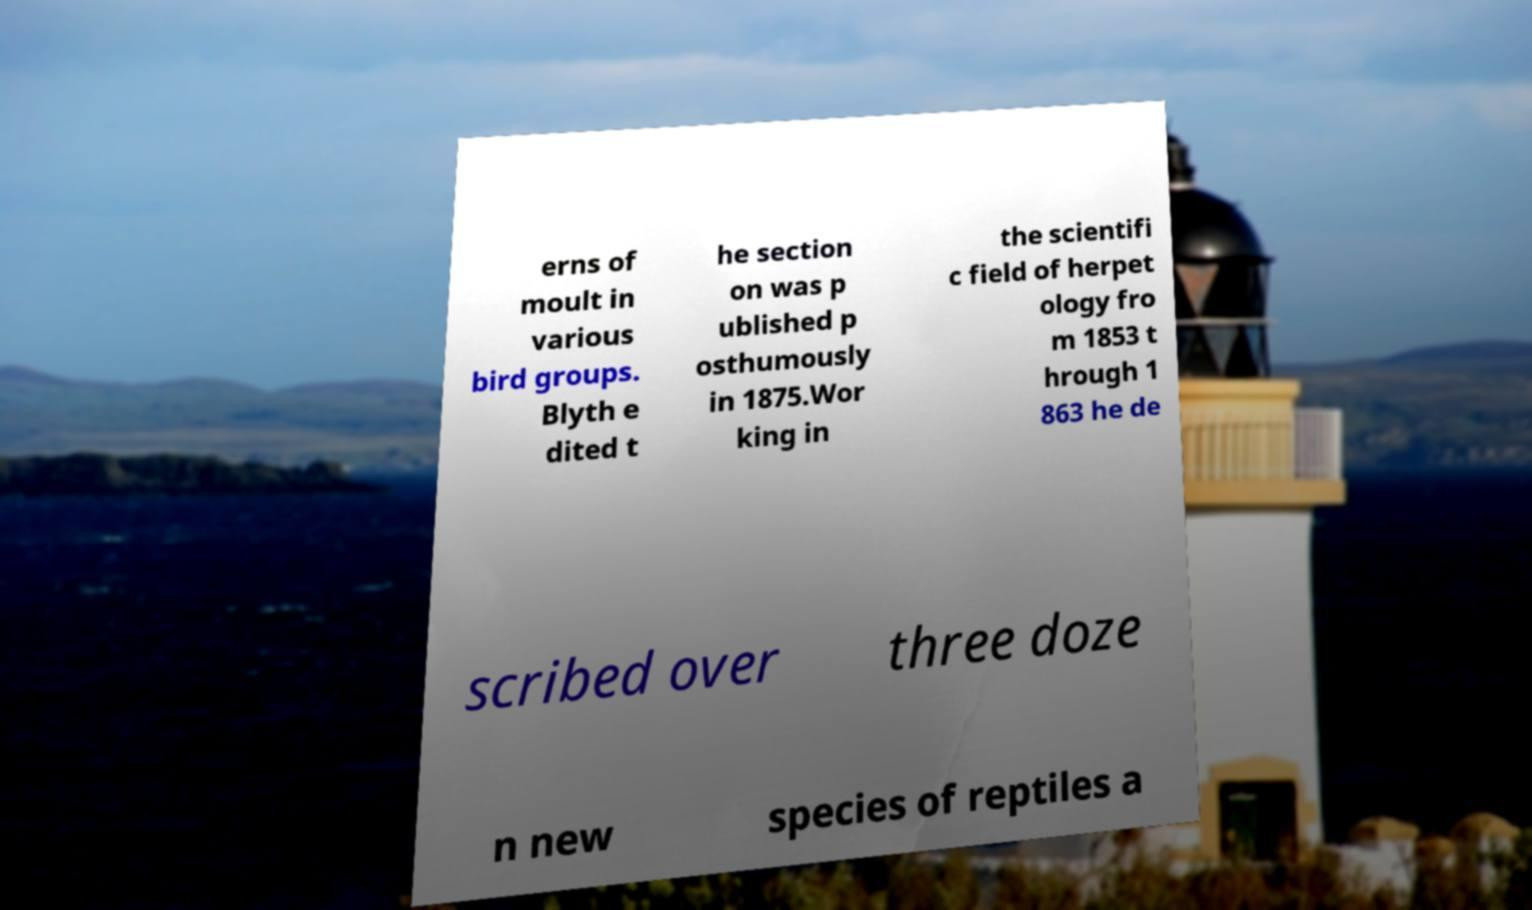Please read and relay the text visible in this image. What does it say? erns of moult in various bird groups. Blyth e dited t he section on was p ublished p osthumously in 1875.Wor king in the scientifi c field of herpet ology fro m 1853 t hrough 1 863 he de scribed over three doze n new species of reptiles a 